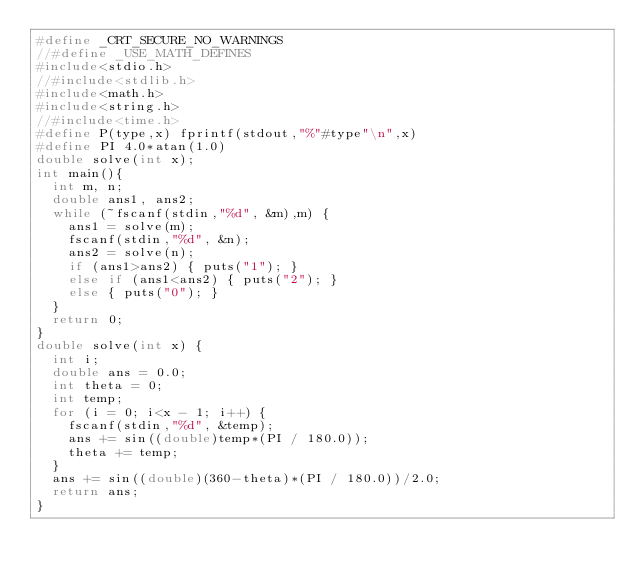Convert code to text. <code><loc_0><loc_0><loc_500><loc_500><_C_>#define _CRT_SECURE_NO_WARNINGS
//#define _USE_MATH_DEFINES
#include<stdio.h>
//#include<stdlib.h>
#include<math.h>
#include<string.h>
//#include<time.h>
#define P(type,x) fprintf(stdout,"%"#type"\n",x)
#define PI 4.0*atan(1.0)
double solve(int x);
int main(){
	int m, n;
	double ans1, ans2;
	while (~fscanf(stdin,"%d", &m),m) {
		ans1 = solve(m);
		fscanf(stdin,"%d", &n);
		ans2 = solve(n);
		if (ans1>ans2) { puts("1"); }
		else if (ans1<ans2) { puts("2"); }
		else { puts("0"); }
	}
	return 0;
}
double solve(int x) {
	int i;
	double ans = 0.0;
	int theta = 0;
	int temp;
	for (i = 0; i<x - 1; i++) {
		fscanf(stdin,"%d", &temp);
		ans += sin((double)temp*(PI / 180.0));
		theta += temp;
	}
	ans += sin((double)(360-theta)*(PI / 180.0))/2.0;
	return ans;
}</code> 